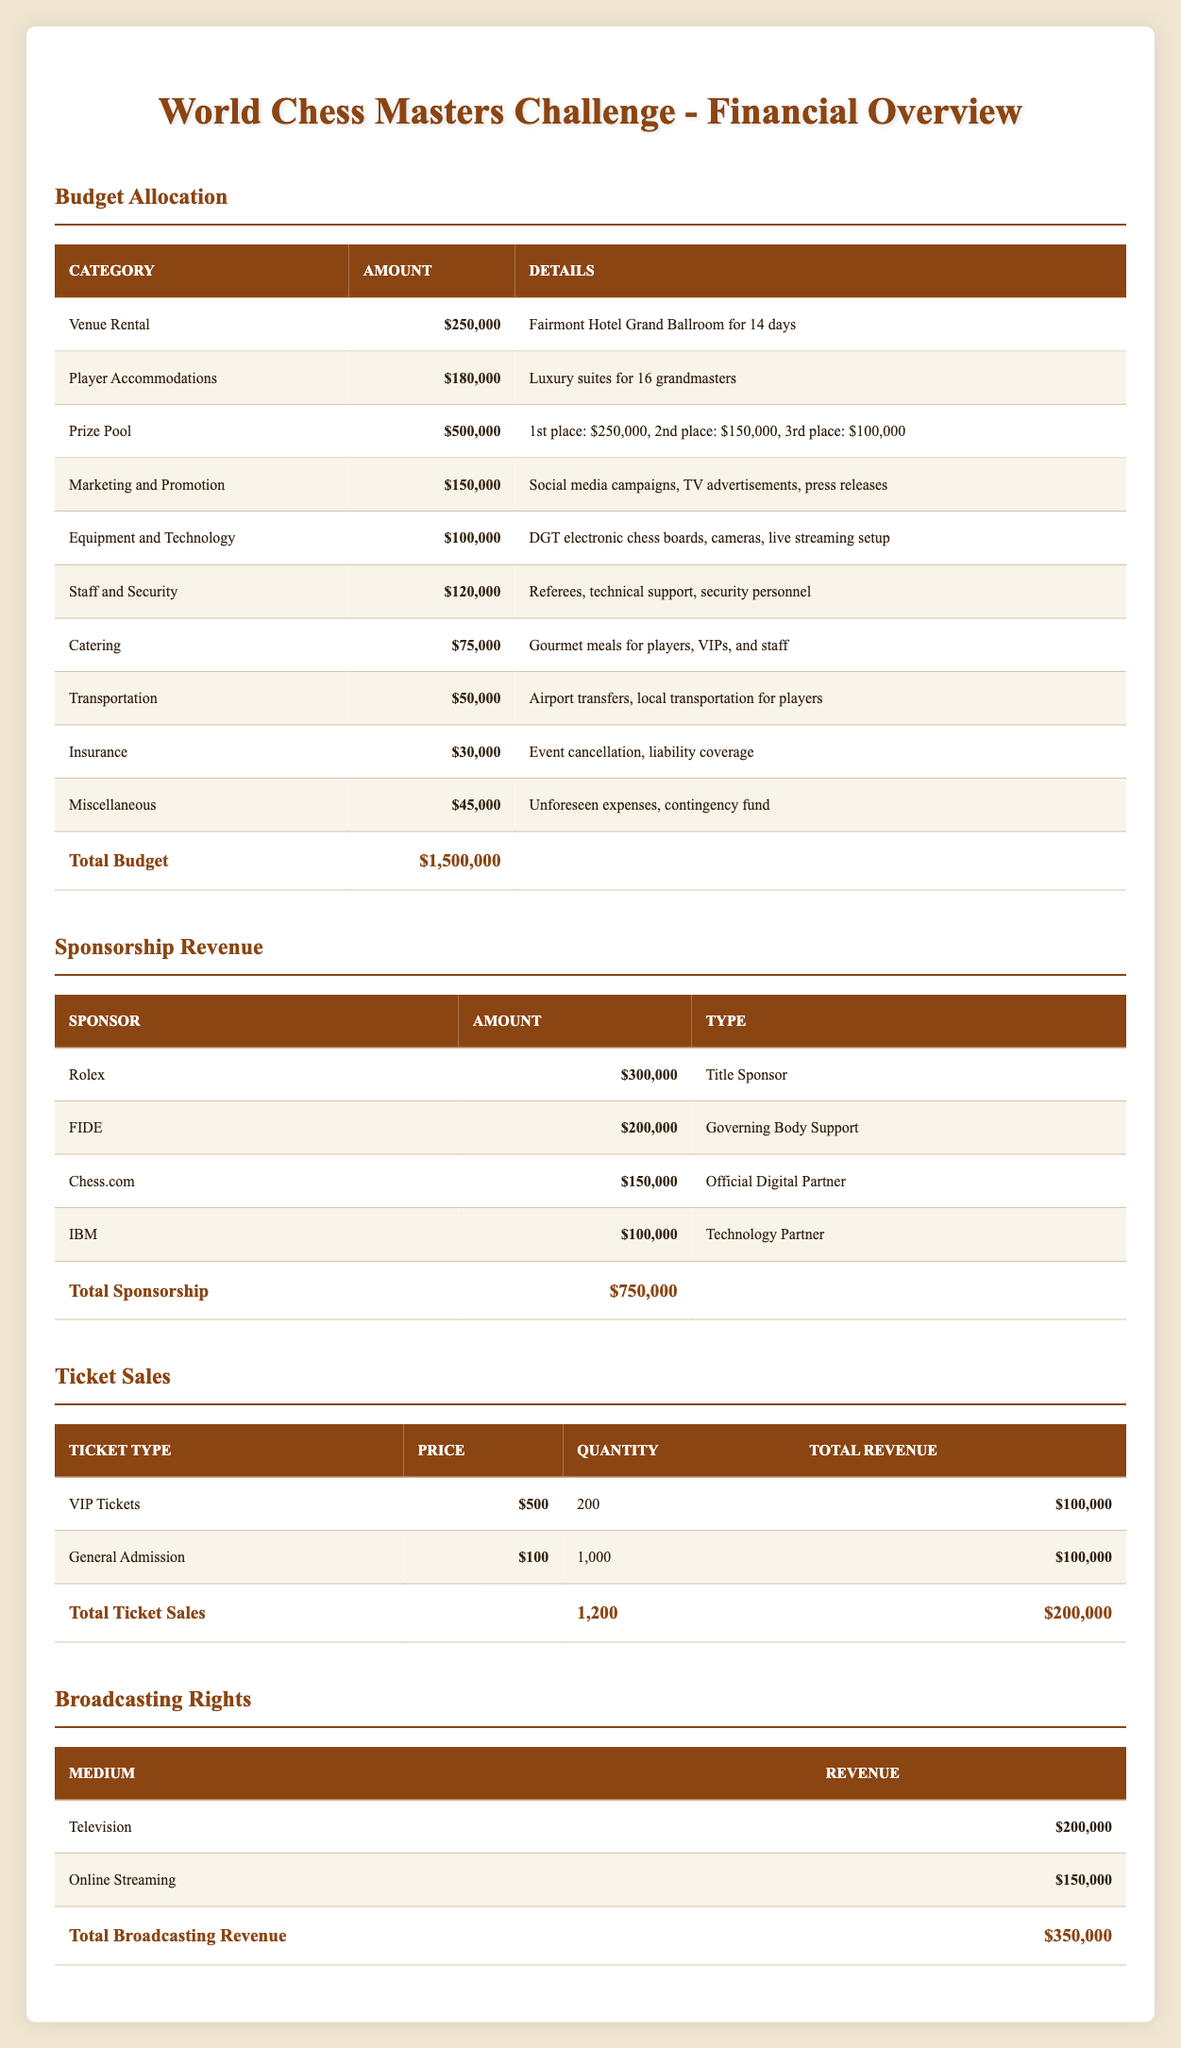What is the total budget for the World Chess Masters Challenge? The total budget is stated directly in the table under the "Budget Allocation" section. It is mentioned as $1,500,000.
Answer: $1,500,000 How much is allocated to the Prize Pool? The budget allocated to the Prize Pool is specified in the table under the "Budget Allocation" section, listed as $500,000.
Answer: $500,000 What is the total revenue from Ticket Sales? To find the total revenue from Ticket Sales, we look at the "Total Ticket Sales" row in the respective table, which sums the revenues from VIP Tickets and General Admission tickets and shows a total of $200,000.
Answer: $200,000 Does the championship have a sponsor providing more than $250,000? Yes, Rolex is listed as a Title Sponsor with an amount of $300,000 in the "Sponsorship Revenue" table, so this statement is true.
Answer: Yes What percentage of the total budget is allocated to Catering? The amount for Catering is $75,000. To find the percentage of the total budget it represents, we use the formula (Catering Amount / Total Budget) * 100. So, ($75,000 / $1,500,000) * 100 = 5%.
Answer: 5% What is the combined revenue from Broadcasting Rights? The revenue from Broadcasting Rights is detailed in the table under the "Broadcasting Rights" section, where Television revenue is $200,000 and Online Streaming is $150,000. Adding these amounts together gives $200,000 + $150,000 = $350,000.
Answer: $350,000 How much more is spent on Player Accommodations than on Transportation? Player Accommodations cost $180,000 and Transportation costs $50,000. The difference is calculated as $180,000 - $50,000 = $130,000, showing how much more is spent.
Answer: $130,000 Is the total amount from Sponsorships greater than the total budget for Venue Rental? The total from Sponsorships is $750,000. The budget allocated for Venue Rental is $250,000. Comparing these amounts, $750,000 is indeed greater than $250,000.
Answer: Yes What is the average amount allocated per category in the Budget Allocation? There are 10 categories listed, with a total budget of $1,500,000. To find the average, divide the total budget by the number of categories: $1,500,000 / 10 = $150,000.
Answer: $150,000 